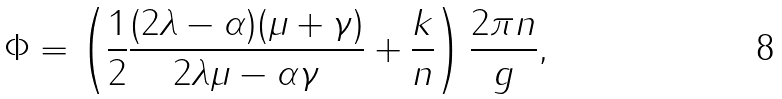<formula> <loc_0><loc_0><loc_500><loc_500>\Phi = \left ( \frac { 1 } { 2 } \frac { ( 2 \lambda - \alpha ) ( \mu + \gamma ) } { 2 \lambda \mu - \alpha \gamma } + \frac { k } { n } \right ) \frac { 2 \pi n } { g } ,</formula> 